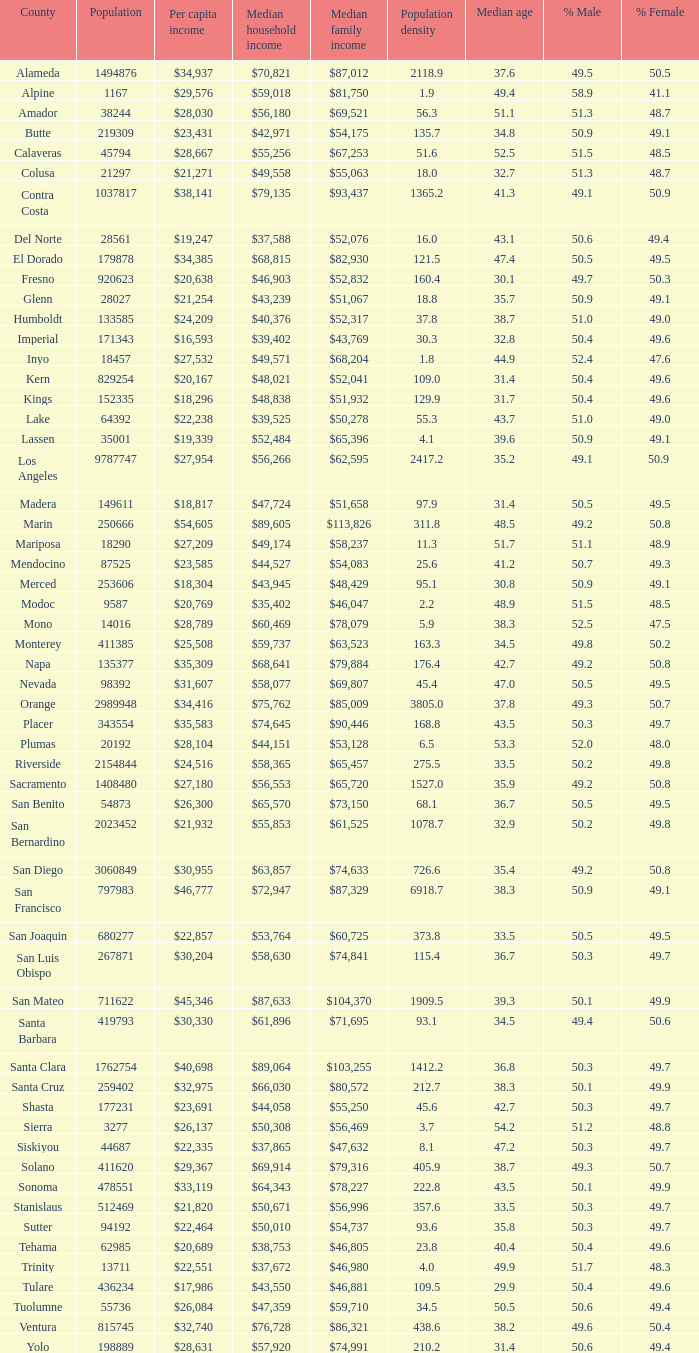Name the median family income for riverside $65,457. 